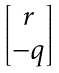<formula> <loc_0><loc_0><loc_500><loc_500>\begin{bmatrix} r \\ - q \end{bmatrix}</formula> 